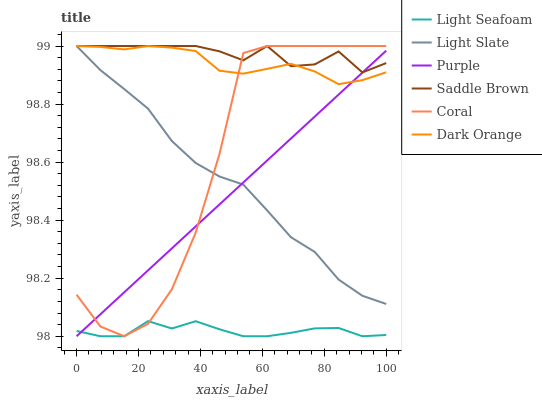Does Light Seafoam have the minimum area under the curve?
Answer yes or no. Yes. Does Saddle Brown have the maximum area under the curve?
Answer yes or no. Yes. Does Light Slate have the minimum area under the curve?
Answer yes or no. No. Does Light Slate have the maximum area under the curve?
Answer yes or no. No. Is Purple the smoothest?
Answer yes or no. Yes. Is Coral the roughest?
Answer yes or no. Yes. Is Light Slate the smoothest?
Answer yes or no. No. Is Light Slate the roughest?
Answer yes or no. No. Does Light Slate have the lowest value?
Answer yes or no. No. Does Purple have the highest value?
Answer yes or no. No. Is Light Seafoam less than Dark Orange?
Answer yes or no. Yes. Is Light Slate greater than Light Seafoam?
Answer yes or no. Yes. Does Light Seafoam intersect Dark Orange?
Answer yes or no. No. 